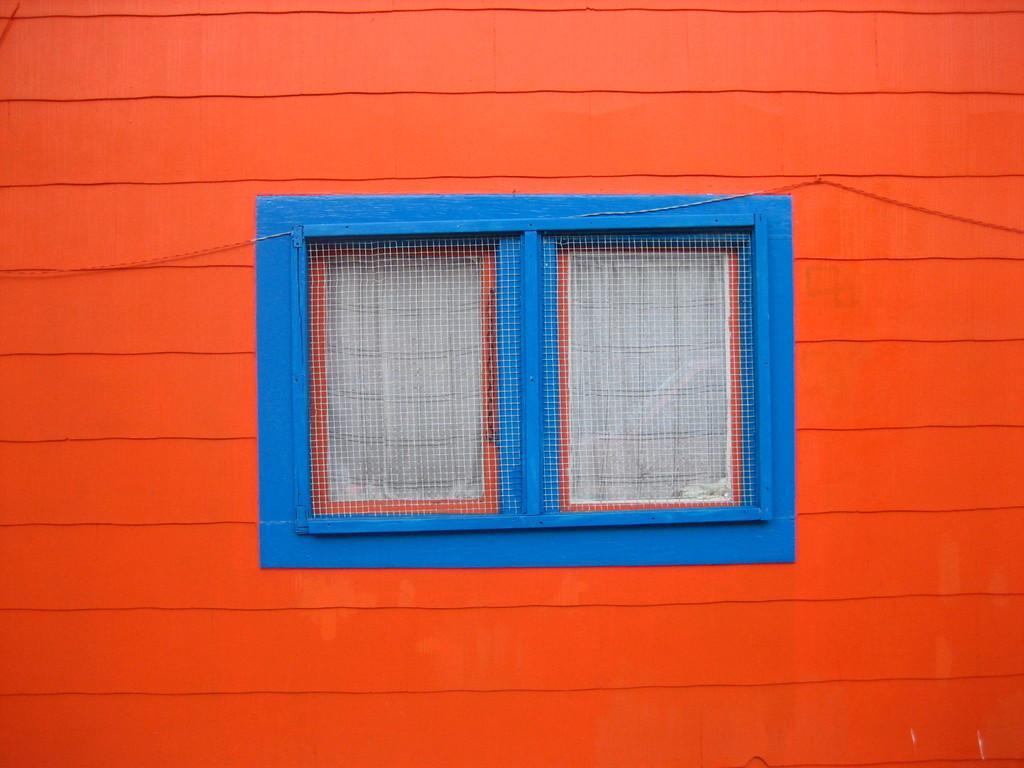Describe this image in one or two sentences. In this image, I can see a window with the doors. This is a mesh, which is attached to a window. I think this is a building wall, which is orange in color. 